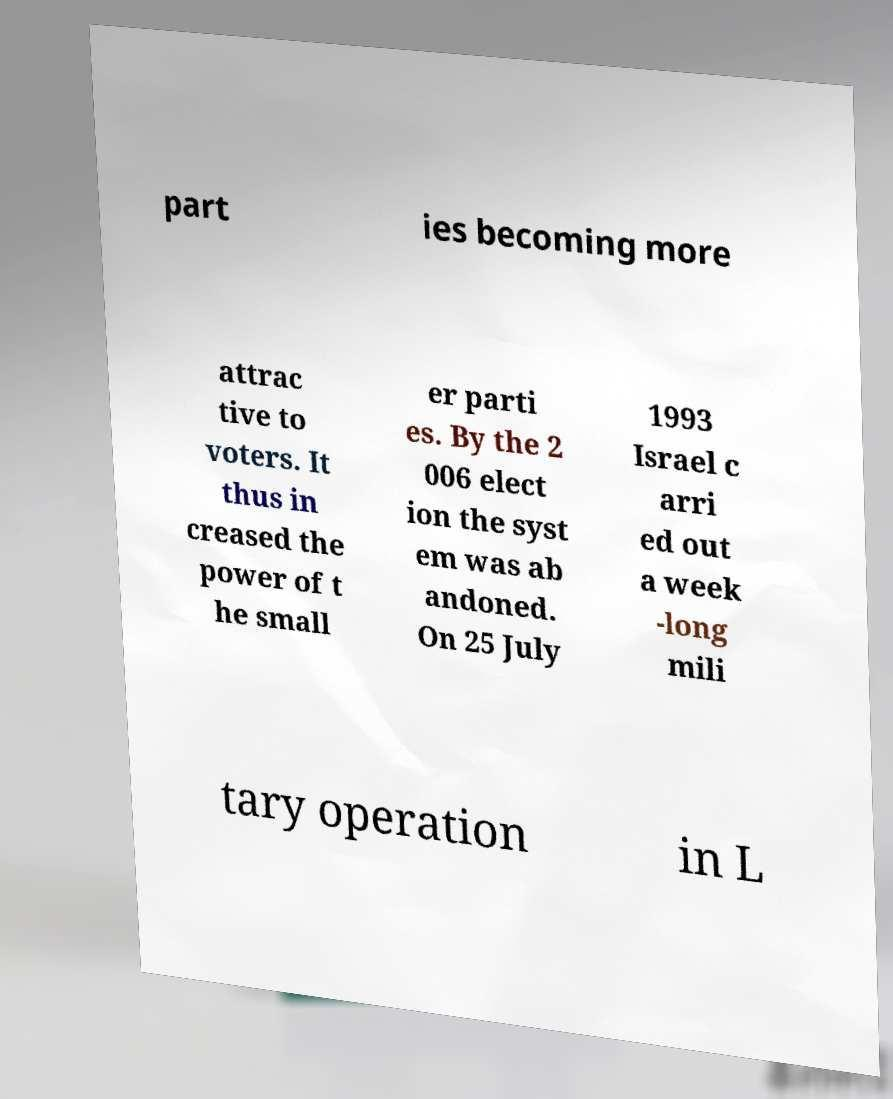Can you read and provide the text displayed in the image?This photo seems to have some interesting text. Can you extract and type it out for me? part ies becoming more attrac tive to voters. It thus in creased the power of t he small er parti es. By the 2 006 elect ion the syst em was ab andoned. On 25 July 1993 Israel c arri ed out a week -long mili tary operation in L 